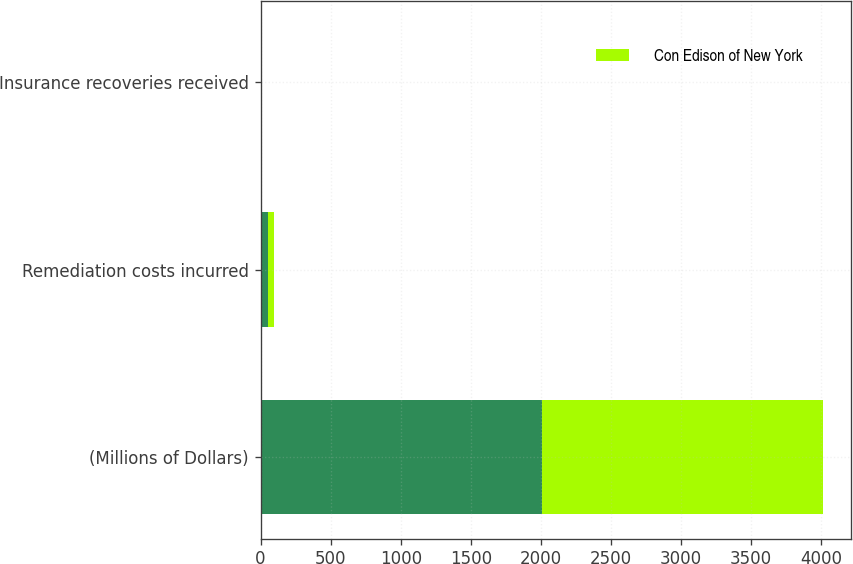Convert chart to OTSL. <chart><loc_0><loc_0><loc_500><loc_500><stacked_bar_chart><ecel><fcel>(Millions of Dollars)<fcel>Remediation costs incurred<fcel>Insurance recoveries received<nl><fcel>nan<fcel>2007<fcel>50<fcel>1<nl><fcel>Con Edison of New York<fcel>2007<fcel>42<fcel>1<nl></chart> 